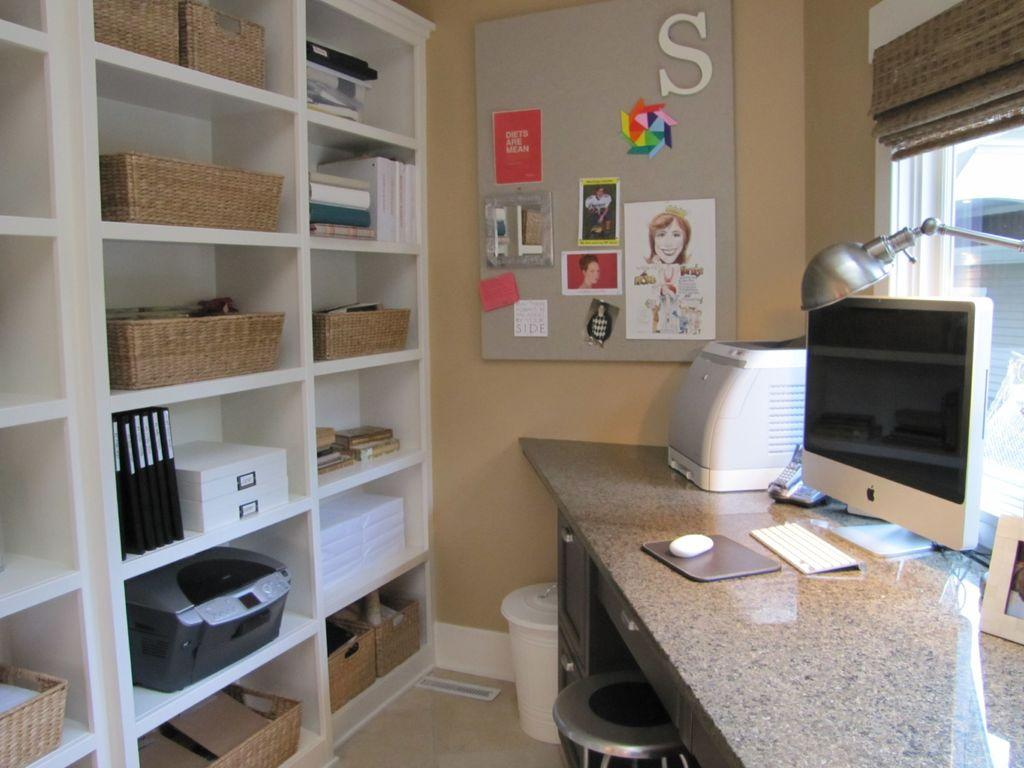<image>
Share a concise interpretation of the image provided. A home office with a corner desk by a window and a bulletin board on the wall that has a large letter S near the top. 